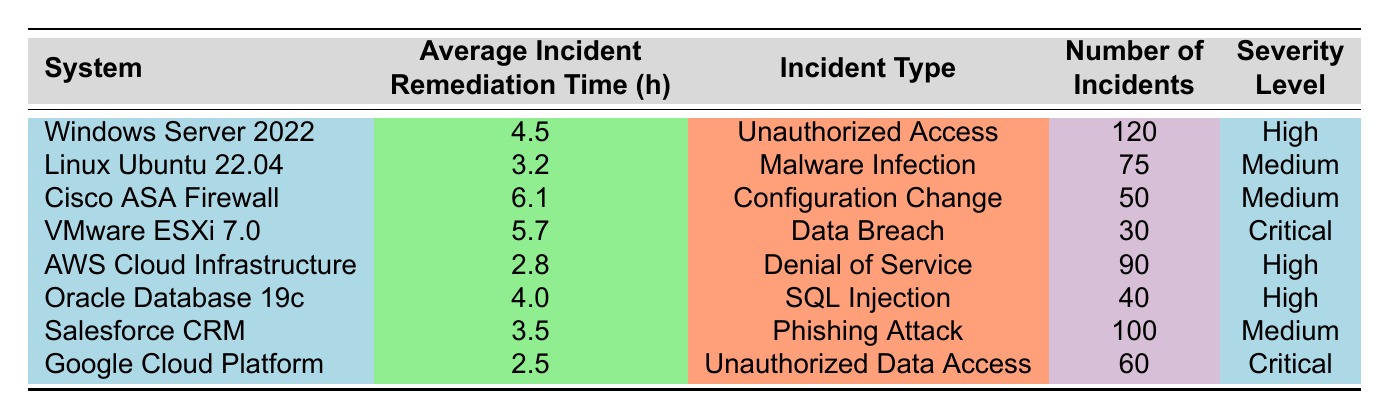What is the average incident remediation time for Google Cloud Platform? Referring to the table, the average incident remediation time for Google Cloud Platform is listed as 2.5 hours.
Answer: 2.5 hours Which system has the highest average incident remediation time? The table indicates that the Cisco ASA Firewall has the highest average incident remediation time, which is 6.1 hours.
Answer: Cisco ASA Firewall How many incidents were associated with the VMware ESXi 7.0 system? The table states that there were 30 incidents associated with the VMware ESXi 7.0 system.
Answer: 30 incidents What is the total number of incidents across all systems? By summing the number of incidents (120 + 75 + 50 + 30 + 90 + 40 + 100 + 60), we get a total of 565 incidents.
Answer: 565 incidents Is the average incident remediation time for AWS Cloud Infrastructure less than 3 hours? The table shows that the average incident remediation time for AWS Cloud Infrastructure is 2.8 hours, which is less than 3 hours.
Answer: Yes What is the average incident remediation time for systems with a severity level classified as Medium? The average remediation times for Medium severity systems are 3.2 (Linux Ubuntu 22.04), 6.1 (Cisco ASA Firewall), and 3.5 (Salesforce CRM). The average is calculated as (3.2 + 6.1 + 3.5)/3 = 4.26 hours.
Answer: 4.26 hours Which incident type is associated with the second lowest average incident remediation time? Checking the average incident remediation times, the incident type associated with the second lowest average is "Malware Infection" from Linux Ubuntu 22.04, which is 3.2 hours.
Answer: Malware Infection If we consider only High severity incidents, what is the average incident remediation time? The High severity incidents are from Windows Server 2022 (4.5 hours), AWS Cloud Infrastructure (2.8 hours), and Oracle Database 19c (4.0 hours). Their average is (4.5 + 2.8 + 4.0)/3 = 3.77 hours.
Answer: 3.77 hours What is the difference in average incident remediation time between the highest and lowest severity levels? The highest average is from Cisco ASA Firewall (6.1 hours) and the lowest is from Google Cloud Platform (2.5 hours). The difference is 6.1 - 2.5 = 3.6 hours.
Answer: 3.6 hours Is there any incident type that has more than 100 recorded incidents? Yes, the incident types "Unauthorized Access" with 120 incidents and "Phishing Attack" with 100 incidents have more than 100 recorded incidents.
Answer: Yes 